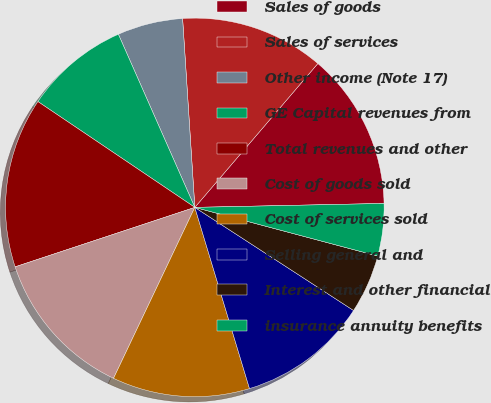Convert chart. <chart><loc_0><loc_0><loc_500><loc_500><pie_chart><fcel>Sales of goods<fcel>Sales of services<fcel>Other income (Note 17)<fcel>GE Capital revenues from<fcel>Total revenues and other<fcel>Cost of goods sold<fcel>Cost of services sold<fcel>Selling general and<fcel>Interest and other financial<fcel>insurance annuity benefits<nl><fcel>13.41%<fcel>12.29%<fcel>5.59%<fcel>8.94%<fcel>14.53%<fcel>12.85%<fcel>11.73%<fcel>11.17%<fcel>5.03%<fcel>4.47%<nl></chart> 